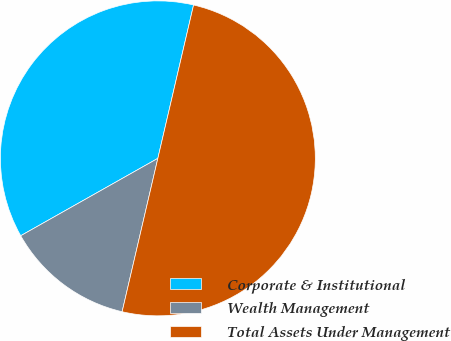<chart> <loc_0><loc_0><loc_500><loc_500><pie_chart><fcel>Corporate & Institutional<fcel>Wealth Management<fcel>Total Assets Under Management<nl><fcel>36.82%<fcel>13.18%<fcel>50.0%<nl></chart> 